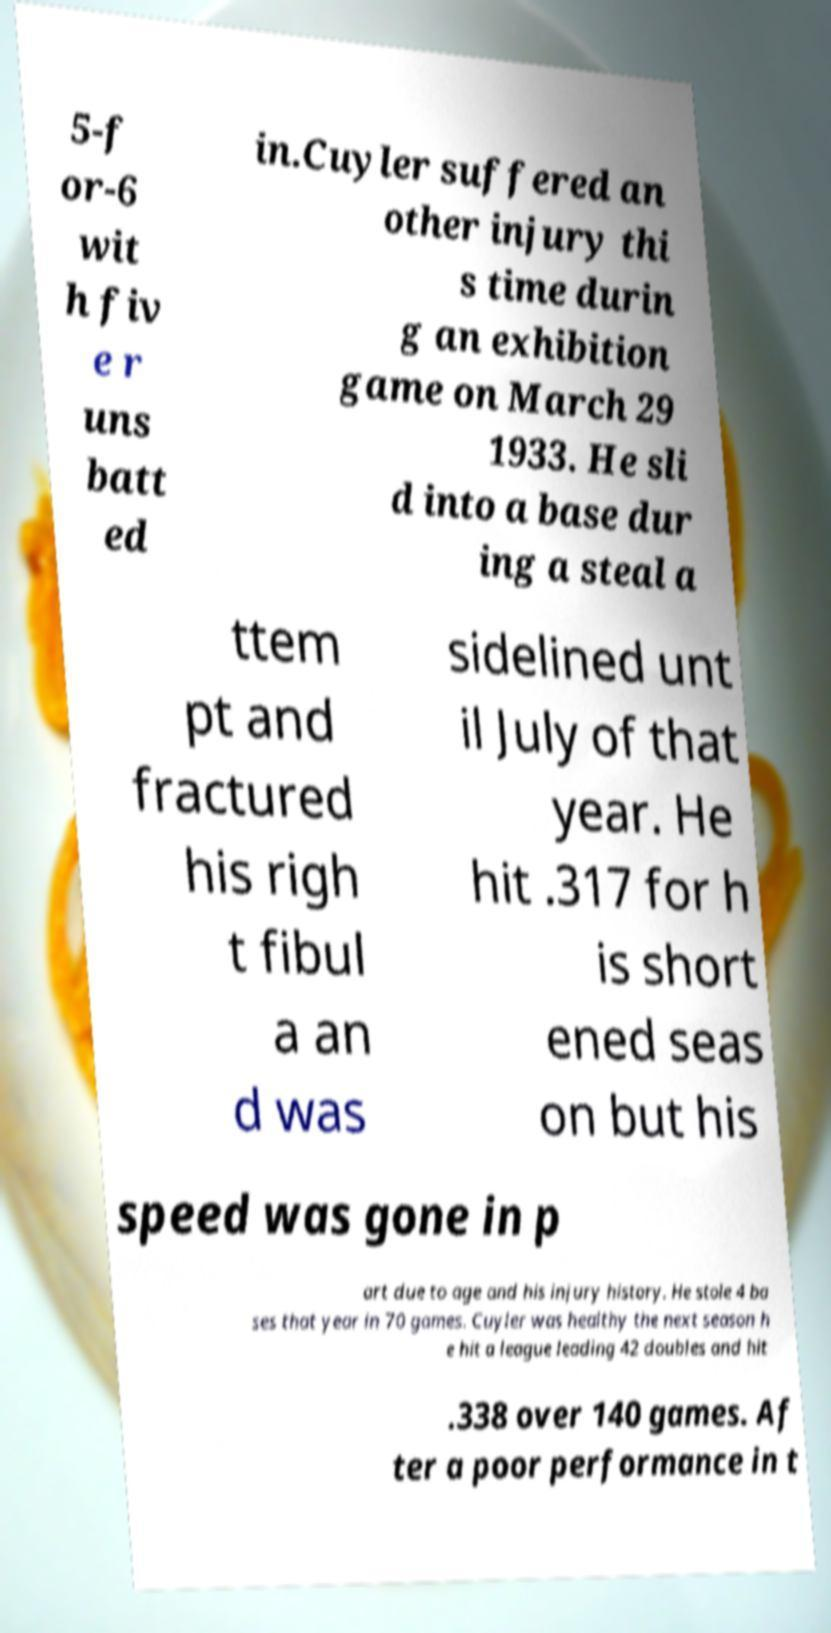I need the written content from this picture converted into text. Can you do that? 5-f or-6 wit h fiv e r uns batt ed in.Cuyler suffered an other injury thi s time durin g an exhibition game on March 29 1933. He sli d into a base dur ing a steal a ttem pt and fractured his righ t fibul a an d was sidelined unt il July of that year. He hit .317 for h is short ened seas on but his speed was gone in p art due to age and his injury history. He stole 4 ba ses that year in 70 games. Cuyler was healthy the next season h e hit a league leading 42 doubles and hit .338 over 140 games. Af ter a poor performance in t 